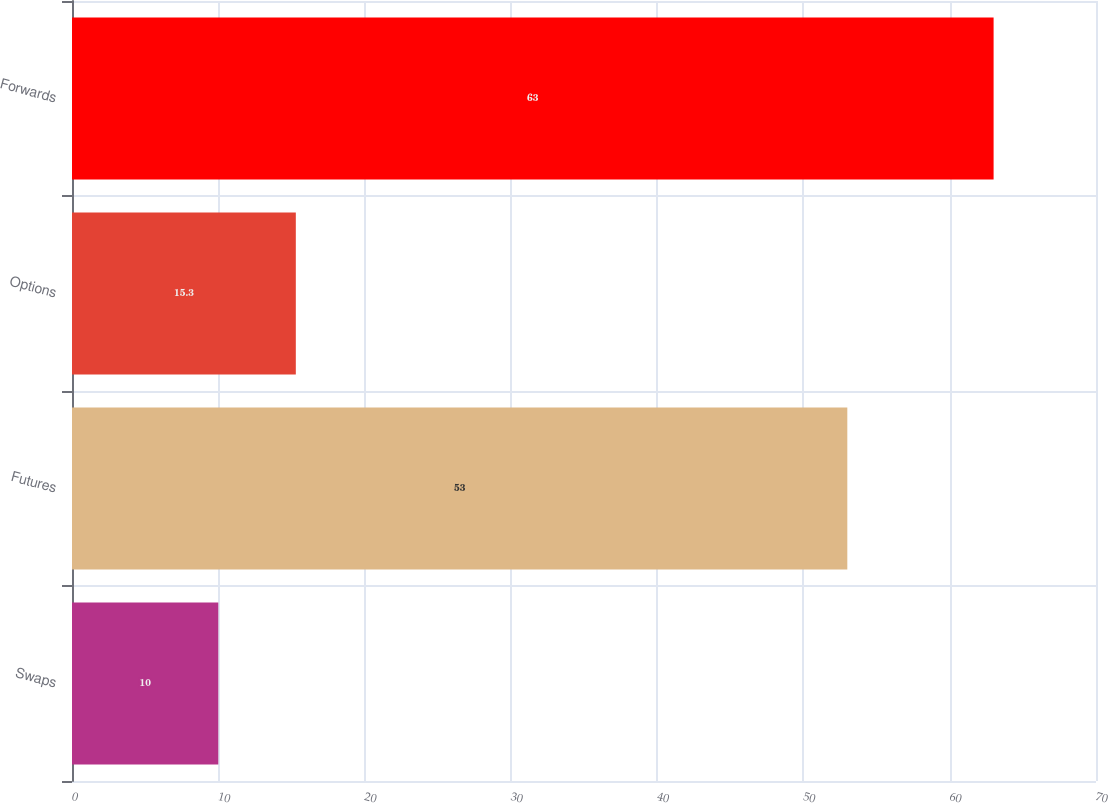<chart> <loc_0><loc_0><loc_500><loc_500><bar_chart><fcel>Swaps<fcel>Futures<fcel>Options<fcel>Forwards<nl><fcel>10<fcel>53<fcel>15.3<fcel>63<nl></chart> 